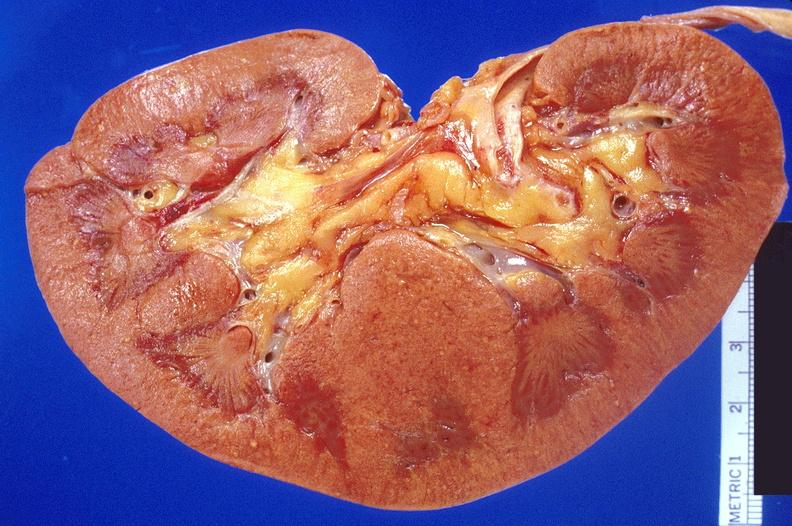where is this?
Answer the question using a single word or phrase. Urinary 